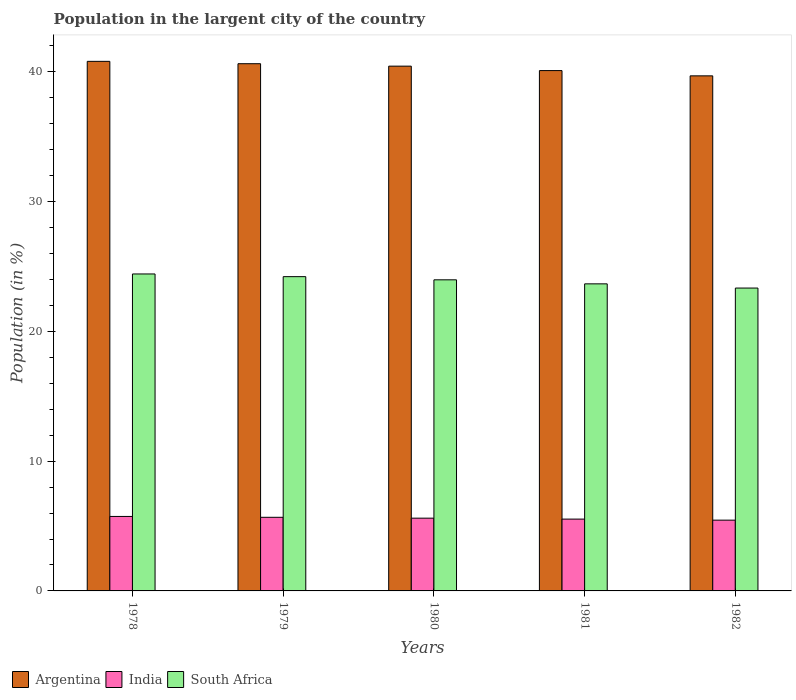How many groups of bars are there?
Make the answer very short. 5. Are the number of bars per tick equal to the number of legend labels?
Make the answer very short. Yes. Are the number of bars on each tick of the X-axis equal?
Give a very brief answer. Yes. How many bars are there on the 3rd tick from the right?
Provide a short and direct response. 3. What is the label of the 2nd group of bars from the left?
Keep it short and to the point. 1979. In how many cases, is the number of bars for a given year not equal to the number of legend labels?
Offer a very short reply. 0. What is the percentage of population in the largent city in Argentina in 1980?
Give a very brief answer. 40.45. Across all years, what is the maximum percentage of population in the largent city in South Africa?
Your answer should be very brief. 24.43. Across all years, what is the minimum percentage of population in the largent city in Argentina?
Your answer should be compact. 39.7. In which year was the percentage of population in the largent city in South Africa maximum?
Make the answer very short. 1978. In which year was the percentage of population in the largent city in India minimum?
Give a very brief answer. 1982. What is the total percentage of population in the largent city in India in the graph?
Your response must be concise. 28.01. What is the difference between the percentage of population in the largent city in Argentina in 1979 and that in 1982?
Provide a succinct answer. 0.94. What is the difference between the percentage of population in the largent city in Argentina in 1981 and the percentage of population in the largent city in India in 1978?
Provide a short and direct response. 34.36. What is the average percentage of population in the largent city in India per year?
Offer a very short reply. 5.6. In the year 1981, what is the difference between the percentage of population in the largent city in South Africa and percentage of population in the largent city in India?
Your answer should be very brief. 18.13. What is the ratio of the percentage of population in the largent city in Argentina in 1979 to that in 1981?
Offer a very short reply. 1.01. Is the difference between the percentage of population in the largent city in South Africa in 1981 and 1982 greater than the difference between the percentage of population in the largent city in India in 1981 and 1982?
Make the answer very short. Yes. What is the difference between the highest and the second highest percentage of population in the largent city in Argentina?
Keep it short and to the point. 0.18. What is the difference between the highest and the lowest percentage of population in the largent city in South Africa?
Offer a terse response. 1.09. In how many years, is the percentage of population in the largent city in South Africa greater than the average percentage of population in the largent city in South Africa taken over all years?
Your response must be concise. 3. What does the 2nd bar from the left in 1979 represents?
Your answer should be compact. India. What does the 3rd bar from the right in 1980 represents?
Provide a succinct answer. Argentina. Is it the case that in every year, the sum of the percentage of population in the largent city in Argentina and percentage of population in the largent city in India is greater than the percentage of population in the largent city in South Africa?
Offer a terse response. Yes. Does the graph contain any zero values?
Provide a succinct answer. No. Does the graph contain grids?
Give a very brief answer. No. How many legend labels are there?
Offer a terse response. 3. What is the title of the graph?
Provide a short and direct response. Population in the largent city of the country. Does "Palau" appear as one of the legend labels in the graph?
Your answer should be very brief. No. What is the Population (in %) in Argentina in 1978?
Offer a very short reply. 40.82. What is the Population (in %) of India in 1978?
Give a very brief answer. 5.74. What is the Population (in %) in South Africa in 1978?
Give a very brief answer. 24.43. What is the Population (in %) of Argentina in 1979?
Ensure brevity in your answer.  40.63. What is the Population (in %) in India in 1979?
Provide a succinct answer. 5.67. What is the Population (in %) of South Africa in 1979?
Your response must be concise. 24.22. What is the Population (in %) in Argentina in 1980?
Provide a short and direct response. 40.45. What is the Population (in %) in India in 1980?
Offer a very short reply. 5.61. What is the Population (in %) in South Africa in 1980?
Your response must be concise. 23.98. What is the Population (in %) of Argentina in 1981?
Your answer should be compact. 40.1. What is the Population (in %) of India in 1981?
Provide a succinct answer. 5.54. What is the Population (in %) of South Africa in 1981?
Keep it short and to the point. 23.67. What is the Population (in %) of Argentina in 1982?
Your answer should be very brief. 39.7. What is the Population (in %) of India in 1982?
Provide a short and direct response. 5.45. What is the Population (in %) in South Africa in 1982?
Offer a very short reply. 23.34. Across all years, what is the maximum Population (in %) in Argentina?
Your response must be concise. 40.82. Across all years, what is the maximum Population (in %) of India?
Provide a succinct answer. 5.74. Across all years, what is the maximum Population (in %) of South Africa?
Your answer should be compact. 24.43. Across all years, what is the minimum Population (in %) in Argentina?
Offer a very short reply. 39.7. Across all years, what is the minimum Population (in %) in India?
Offer a very short reply. 5.45. Across all years, what is the minimum Population (in %) in South Africa?
Provide a short and direct response. 23.34. What is the total Population (in %) in Argentina in the graph?
Provide a succinct answer. 201.7. What is the total Population (in %) in India in the graph?
Provide a succinct answer. 28.01. What is the total Population (in %) of South Africa in the graph?
Offer a very short reply. 119.64. What is the difference between the Population (in %) of Argentina in 1978 and that in 1979?
Give a very brief answer. 0.18. What is the difference between the Population (in %) of India in 1978 and that in 1979?
Keep it short and to the point. 0.07. What is the difference between the Population (in %) of South Africa in 1978 and that in 1979?
Give a very brief answer. 0.21. What is the difference between the Population (in %) of Argentina in 1978 and that in 1980?
Ensure brevity in your answer.  0.37. What is the difference between the Population (in %) of India in 1978 and that in 1980?
Your answer should be compact. 0.13. What is the difference between the Population (in %) in South Africa in 1978 and that in 1980?
Provide a short and direct response. 0.45. What is the difference between the Population (in %) of Argentina in 1978 and that in 1981?
Keep it short and to the point. 0.71. What is the difference between the Population (in %) of India in 1978 and that in 1981?
Provide a succinct answer. 0.2. What is the difference between the Population (in %) in South Africa in 1978 and that in 1981?
Your answer should be very brief. 0.76. What is the difference between the Population (in %) in Argentina in 1978 and that in 1982?
Give a very brief answer. 1.12. What is the difference between the Population (in %) in India in 1978 and that in 1982?
Your answer should be compact. 0.29. What is the difference between the Population (in %) in South Africa in 1978 and that in 1982?
Provide a succinct answer. 1.09. What is the difference between the Population (in %) of Argentina in 1979 and that in 1980?
Provide a short and direct response. 0.19. What is the difference between the Population (in %) in India in 1979 and that in 1980?
Give a very brief answer. 0.07. What is the difference between the Population (in %) in South Africa in 1979 and that in 1980?
Make the answer very short. 0.24. What is the difference between the Population (in %) in Argentina in 1979 and that in 1981?
Provide a short and direct response. 0.53. What is the difference between the Population (in %) of India in 1979 and that in 1981?
Make the answer very short. 0.14. What is the difference between the Population (in %) in South Africa in 1979 and that in 1981?
Your response must be concise. 0.56. What is the difference between the Population (in %) of Argentina in 1979 and that in 1982?
Make the answer very short. 0.94. What is the difference between the Population (in %) of India in 1979 and that in 1982?
Ensure brevity in your answer.  0.22. What is the difference between the Population (in %) in South Africa in 1979 and that in 1982?
Offer a very short reply. 0.88. What is the difference between the Population (in %) in Argentina in 1980 and that in 1981?
Offer a terse response. 0.34. What is the difference between the Population (in %) in India in 1980 and that in 1981?
Give a very brief answer. 0.07. What is the difference between the Population (in %) of South Africa in 1980 and that in 1981?
Offer a very short reply. 0.31. What is the difference between the Population (in %) in Argentina in 1980 and that in 1982?
Make the answer very short. 0.75. What is the difference between the Population (in %) in India in 1980 and that in 1982?
Keep it short and to the point. 0.15. What is the difference between the Population (in %) of South Africa in 1980 and that in 1982?
Provide a short and direct response. 0.63. What is the difference between the Population (in %) in Argentina in 1981 and that in 1982?
Provide a succinct answer. 0.41. What is the difference between the Population (in %) in India in 1981 and that in 1982?
Give a very brief answer. 0.08. What is the difference between the Population (in %) of South Africa in 1981 and that in 1982?
Give a very brief answer. 0.32. What is the difference between the Population (in %) in Argentina in 1978 and the Population (in %) in India in 1979?
Your response must be concise. 35.14. What is the difference between the Population (in %) of Argentina in 1978 and the Population (in %) of South Africa in 1979?
Offer a terse response. 16.59. What is the difference between the Population (in %) in India in 1978 and the Population (in %) in South Africa in 1979?
Your response must be concise. -18.48. What is the difference between the Population (in %) in Argentina in 1978 and the Population (in %) in India in 1980?
Make the answer very short. 35.21. What is the difference between the Population (in %) in Argentina in 1978 and the Population (in %) in South Africa in 1980?
Offer a very short reply. 16.84. What is the difference between the Population (in %) of India in 1978 and the Population (in %) of South Africa in 1980?
Offer a terse response. -18.24. What is the difference between the Population (in %) in Argentina in 1978 and the Population (in %) in India in 1981?
Ensure brevity in your answer.  35.28. What is the difference between the Population (in %) of Argentina in 1978 and the Population (in %) of South Africa in 1981?
Make the answer very short. 17.15. What is the difference between the Population (in %) of India in 1978 and the Population (in %) of South Africa in 1981?
Offer a very short reply. -17.93. What is the difference between the Population (in %) of Argentina in 1978 and the Population (in %) of India in 1982?
Keep it short and to the point. 35.36. What is the difference between the Population (in %) in Argentina in 1978 and the Population (in %) in South Africa in 1982?
Your answer should be very brief. 17.47. What is the difference between the Population (in %) of India in 1978 and the Population (in %) of South Africa in 1982?
Offer a very short reply. -17.6. What is the difference between the Population (in %) in Argentina in 1979 and the Population (in %) in India in 1980?
Provide a succinct answer. 35.03. What is the difference between the Population (in %) of Argentina in 1979 and the Population (in %) of South Africa in 1980?
Ensure brevity in your answer.  16.66. What is the difference between the Population (in %) of India in 1979 and the Population (in %) of South Africa in 1980?
Keep it short and to the point. -18.3. What is the difference between the Population (in %) of Argentina in 1979 and the Population (in %) of India in 1981?
Keep it short and to the point. 35.1. What is the difference between the Population (in %) in Argentina in 1979 and the Population (in %) in South Africa in 1981?
Provide a short and direct response. 16.97. What is the difference between the Population (in %) of India in 1979 and the Population (in %) of South Africa in 1981?
Provide a short and direct response. -17.99. What is the difference between the Population (in %) in Argentina in 1979 and the Population (in %) in India in 1982?
Ensure brevity in your answer.  35.18. What is the difference between the Population (in %) in Argentina in 1979 and the Population (in %) in South Africa in 1982?
Offer a terse response. 17.29. What is the difference between the Population (in %) of India in 1979 and the Population (in %) of South Africa in 1982?
Provide a short and direct response. -17.67. What is the difference between the Population (in %) of Argentina in 1980 and the Population (in %) of India in 1981?
Your response must be concise. 34.91. What is the difference between the Population (in %) of Argentina in 1980 and the Population (in %) of South Africa in 1981?
Your answer should be very brief. 16.78. What is the difference between the Population (in %) in India in 1980 and the Population (in %) in South Africa in 1981?
Make the answer very short. -18.06. What is the difference between the Population (in %) of Argentina in 1980 and the Population (in %) of India in 1982?
Provide a short and direct response. 34.99. What is the difference between the Population (in %) of Argentina in 1980 and the Population (in %) of South Africa in 1982?
Offer a very short reply. 17.1. What is the difference between the Population (in %) in India in 1980 and the Population (in %) in South Africa in 1982?
Provide a succinct answer. -17.74. What is the difference between the Population (in %) in Argentina in 1981 and the Population (in %) in India in 1982?
Make the answer very short. 34.65. What is the difference between the Population (in %) in Argentina in 1981 and the Population (in %) in South Africa in 1982?
Keep it short and to the point. 16.76. What is the difference between the Population (in %) in India in 1981 and the Population (in %) in South Africa in 1982?
Keep it short and to the point. -17.81. What is the average Population (in %) of Argentina per year?
Make the answer very short. 40.34. What is the average Population (in %) of India per year?
Ensure brevity in your answer.  5.6. What is the average Population (in %) in South Africa per year?
Keep it short and to the point. 23.93. In the year 1978, what is the difference between the Population (in %) in Argentina and Population (in %) in India?
Offer a terse response. 35.08. In the year 1978, what is the difference between the Population (in %) in Argentina and Population (in %) in South Africa?
Keep it short and to the point. 16.39. In the year 1978, what is the difference between the Population (in %) of India and Population (in %) of South Africa?
Make the answer very short. -18.69. In the year 1979, what is the difference between the Population (in %) of Argentina and Population (in %) of India?
Offer a terse response. 34.96. In the year 1979, what is the difference between the Population (in %) in Argentina and Population (in %) in South Africa?
Offer a very short reply. 16.41. In the year 1979, what is the difference between the Population (in %) in India and Population (in %) in South Africa?
Your answer should be compact. -18.55. In the year 1980, what is the difference between the Population (in %) in Argentina and Population (in %) in India?
Offer a terse response. 34.84. In the year 1980, what is the difference between the Population (in %) in Argentina and Population (in %) in South Africa?
Offer a very short reply. 16.47. In the year 1980, what is the difference between the Population (in %) in India and Population (in %) in South Africa?
Your answer should be very brief. -18.37. In the year 1981, what is the difference between the Population (in %) of Argentina and Population (in %) of India?
Offer a terse response. 34.57. In the year 1981, what is the difference between the Population (in %) in Argentina and Population (in %) in South Africa?
Keep it short and to the point. 16.44. In the year 1981, what is the difference between the Population (in %) of India and Population (in %) of South Africa?
Your answer should be compact. -18.13. In the year 1982, what is the difference between the Population (in %) of Argentina and Population (in %) of India?
Provide a short and direct response. 34.24. In the year 1982, what is the difference between the Population (in %) in Argentina and Population (in %) in South Africa?
Your answer should be very brief. 16.35. In the year 1982, what is the difference between the Population (in %) of India and Population (in %) of South Africa?
Your answer should be very brief. -17.89. What is the ratio of the Population (in %) of Argentina in 1978 to that in 1979?
Your answer should be compact. 1. What is the ratio of the Population (in %) in India in 1978 to that in 1979?
Your answer should be very brief. 1.01. What is the ratio of the Population (in %) of South Africa in 1978 to that in 1979?
Your response must be concise. 1.01. What is the ratio of the Population (in %) in Argentina in 1978 to that in 1980?
Your answer should be compact. 1.01. What is the ratio of the Population (in %) in India in 1978 to that in 1980?
Provide a succinct answer. 1.02. What is the ratio of the Population (in %) in South Africa in 1978 to that in 1980?
Your answer should be compact. 1.02. What is the ratio of the Population (in %) in Argentina in 1978 to that in 1981?
Your answer should be compact. 1.02. What is the ratio of the Population (in %) in India in 1978 to that in 1981?
Offer a very short reply. 1.04. What is the ratio of the Population (in %) of South Africa in 1978 to that in 1981?
Give a very brief answer. 1.03. What is the ratio of the Population (in %) in Argentina in 1978 to that in 1982?
Make the answer very short. 1.03. What is the ratio of the Population (in %) of India in 1978 to that in 1982?
Make the answer very short. 1.05. What is the ratio of the Population (in %) in South Africa in 1978 to that in 1982?
Give a very brief answer. 1.05. What is the ratio of the Population (in %) of India in 1979 to that in 1980?
Provide a short and direct response. 1.01. What is the ratio of the Population (in %) of South Africa in 1979 to that in 1980?
Make the answer very short. 1.01. What is the ratio of the Population (in %) in Argentina in 1979 to that in 1981?
Keep it short and to the point. 1.01. What is the ratio of the Population (in %) of India in 1979 to that in 1981?
Make the answer very short. 1.02. What is the ratio of the Population (in %) of South Africa in 1979 to that in 1981?
Offer a very short reply. 1.02. What is the ratio of the Population (in %) in Argentina in 1979 to that in 1982?
Provide a short and direct response. 1.02. What is the ratio of the Population (in %) of India in 1979 to that in 1982?
Your response must be concise. 1.04. What is the ratio of the Population (in %) in South Africa in 1979 to that in 1982?
Your answer should be very brief. 1.04. What is the ratio of the Population (in %) of Argentina in 1980 to that in 1981?
Offer a very short reply. 1.01. What is the ratio of the Population (in %) in India in 1980 to that in 1981?
Your answer should be compact. 1.01. What is the ratio of the Population (in %) of South Africa in 1980 to that in 1981?
Your response must be concise. 1.01. What is the ratio of the Population (in %) of Argentina in 1980 to that in 1982?
Your answer should be compact. 1.02. What is the ratio of the Population (in %) of India in 1980 to that in 1982?
Offer a terse response. 1.03. What is the ratio of the Population (in %) in South Africa in 1980 to that in 1982?
Ensure brevity in your answer.  1.03. What is the ratio of the Population (in %) of Argentina in 1981 to that in 1982?
Provide a short and direct response. 1.01. What is the ratio of the Population (in %) in India in 1981 to that in 1982?
Make the answer very short. 1.01. What is the ratio of the Population (in %) of South Africa in 1981 to that in 1982?
Your answer should be compact. 1.01. What is the difference between the highest and the second highest Population (in %) of Argentina?
Ensure brevity in your answer.  0.18. What is the difference between the highest and the second highest Population (in %) of India?
Make the answer very short. 0.07. What is the difference between the highest and the second highest Population (in %) of South Africa?
Your answer should be compact. 0.21. What is the difference between the highest and the lowest Population (in %) in Argentina?
Your answer should be very brief. 1.12. What is the difference between the highest and the lowest Population (in %) of India?
Give a very brief answer. 0.29. What is the difference between the highest and the lowest Population (in %) in South Africa?
Keep it short and to the point. 1.09. 